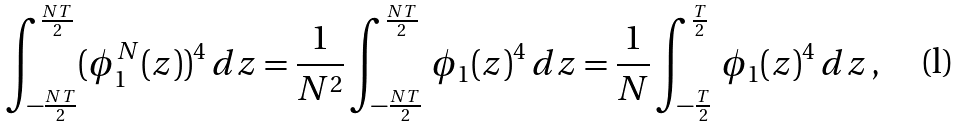<formula> <loc_0><loc_0><loc_500><loc_500>\int _ { - \frac { N T } { 2 } } ^ { \frac { N T } { 2 } } ( \phi _ { 1 } ^ { N } ( z ) ) ^ { 4 } \, d z = \frac { 1 } { N ^ { 2 } } \int _ { - \frac { N T } { 2 } } ^ { \frac { N T } { 2 } } \, \phi _ { 1 } ( z ) ^ { 4 } \, d z = \frac { 1 } { N } \int _ { - \frac { T } { 2 } } ^ { \frac { T } { 2 } } \, \phi _ { 1 } ( z ) ^ { 4 } \, d z \, ,</formula> 